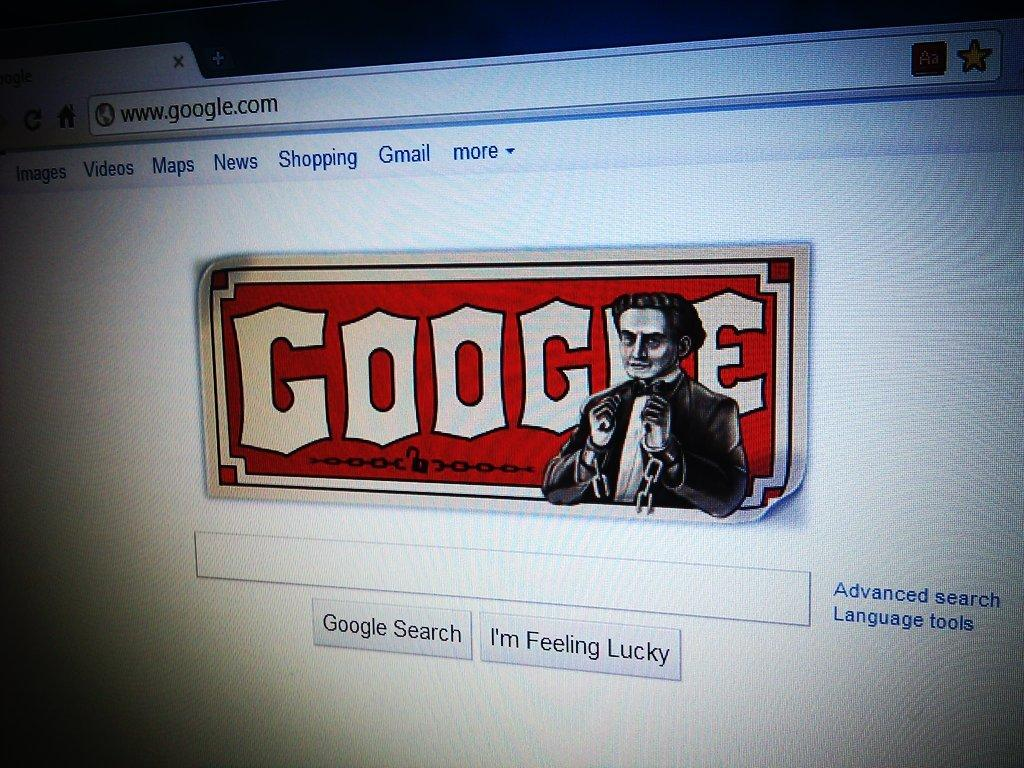<image>
Give a short and clear explanation of the subsequent image. Screen showing a website for Google on it. 